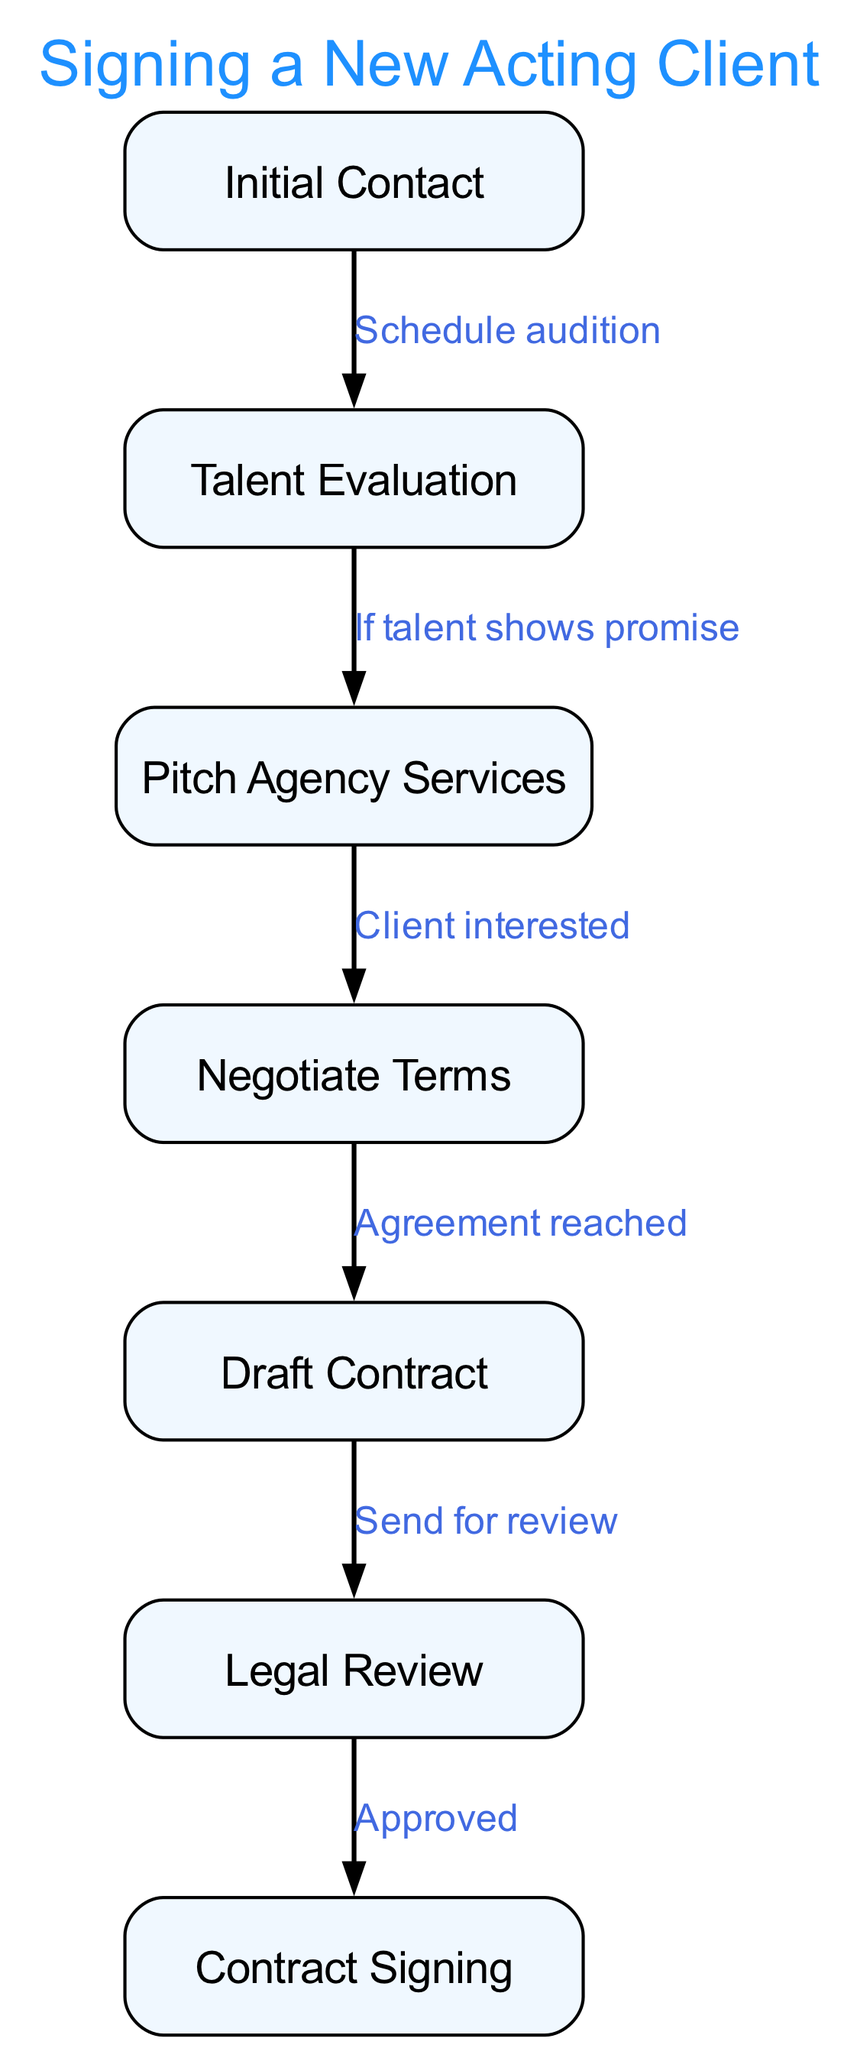What is the first step in the process? The diagram starts with the node labeled "Initial Contact," which represents the very first step in signing a new acting client.
Answer: Initial Contact How many nodes are in the diagram? By counting all the distinct steps represented in the diagram, we see there are a total of 7 nodes listed.
Answer: 7 What is the relation between "Talent Evaluation" and "Pitch Agency Services"? The edge connecting "Talent Evaluation" to "Pitch Agency Services" indicates a conditional relationship that states "If talent shows promise," leading to the next step, which is pitching services.
Answer: If talent shows promise How many edges connect to "Contract Signing"? The diagram indicates that "Contract Signing" is connected by only one edge, which flows from the "Legal Review" node after approval.
Answer: 1 What happens after "Negotiate Terms"? Following "Negotiate Terms," the diagram shows that the next action is to "Draft Contract," indicating that terms have been agreed upon in the previous step.
Answer: Draft Contract Which node represents the legal examination of the contract? The node that specifically highlights the legal examination phase is "Legal Review," indicating this critical step in the overall process.
Answer: Legal Review What do you need to reach the "Contract Signing" node? To reach "Contract Signing," the diagram states that you must first receive "Approved" from the "Legal Review," indicating approval needs to be obtained.
Answer: Approved What is shown as the outcome of the "Pitch Agency Services"? The flow indicates that after pitching the agency's services, the conditional outcome shown is "Client interested," which leads to the next step of negotiating terms.
Answer: Client interested 